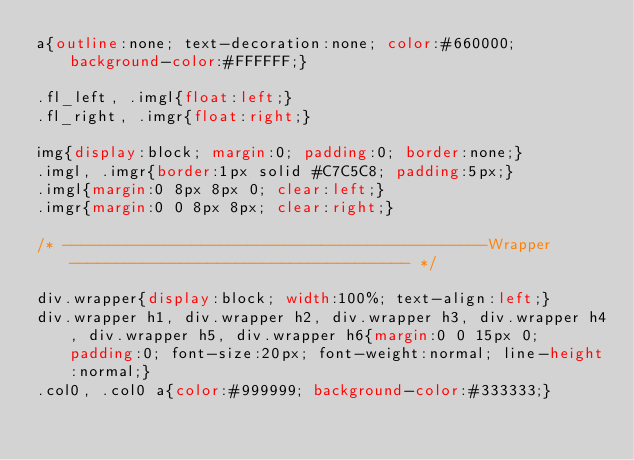<code> <loc_0><loc_0><loc_500><loc_500><_CSS_>a{outline:none; text-decoration:none; color:#660000; background-color:#FFFFFF;}

.fl_left, .imgl{float:left;}
.fl_right, .imgr{float:right;}

img{display:block; margin:0; padding:0; border:none;}
.imgl, .imgr{border:1px solid #C7C5C8; padding:5px;}
.imgl{margin:0 8px 8px 0; clear:left;}
.imgr{margin:0 0 8px 8px; clear:right;}

/* ----------------------------------------------Wrapper------------------------------------- */

div.wrapper{display:block; width:100%; text-align:left;}
div.wrapper h1, div.wrapper h2, div.wrapper h3, div.wrapper h4, div.wrapper h5, div.wrapper h6{margin:0 0 15px 0; padding:0; font-size:20px; font-weight:normal; line-height:normal;}
.col0, .col0 a{color:#999999; background-color:#333333;}</code> 